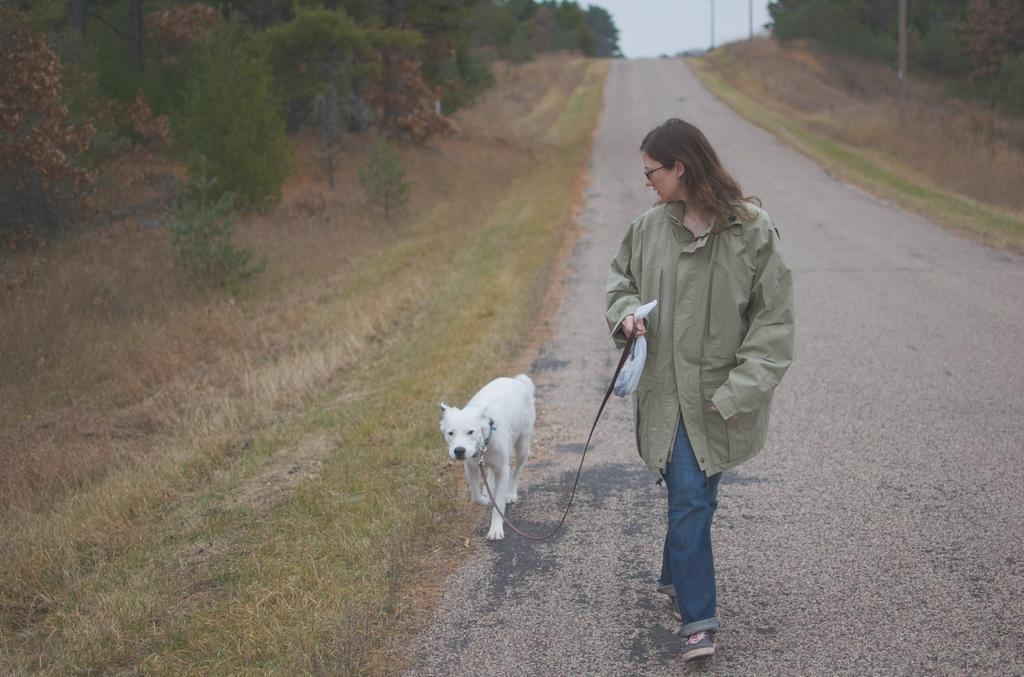Please provide a concise description of this image. In this image there is a woman walking on the road, beside her there is a dog. On the left and right side of the image there are trees. In the background there is the sky. 